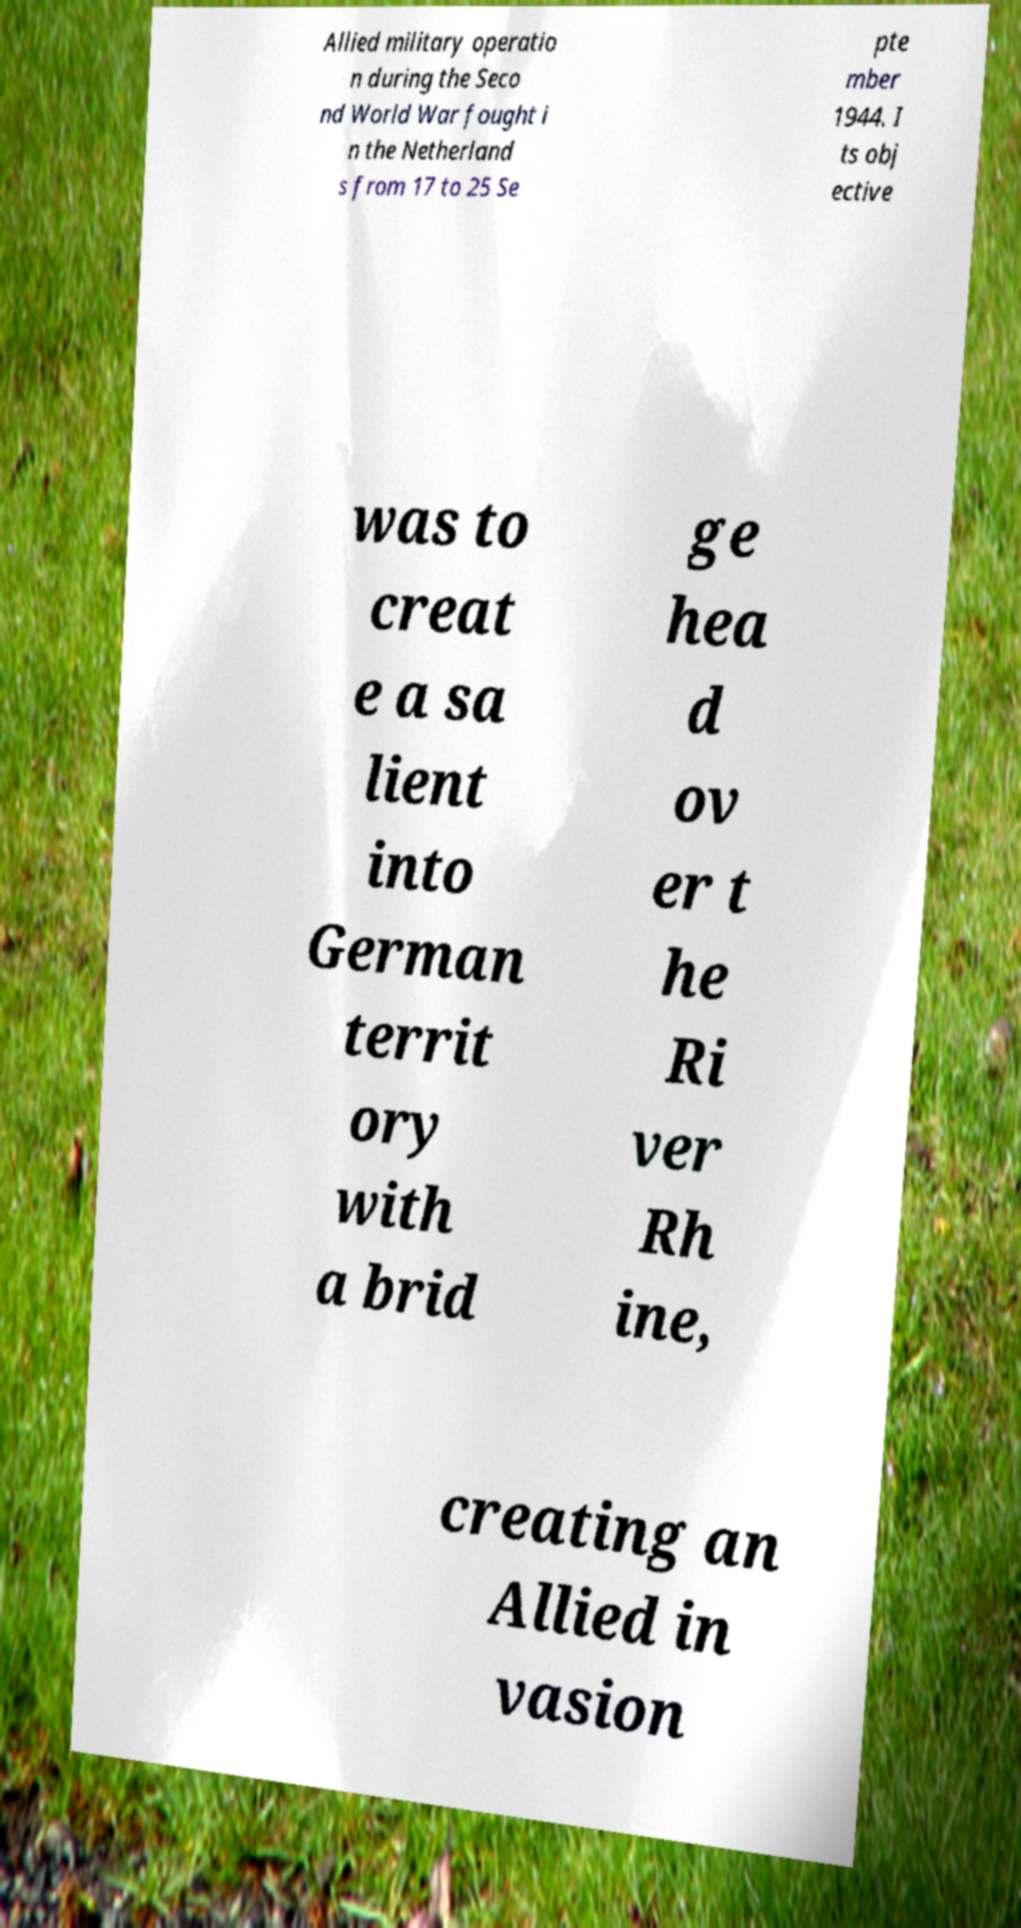There's text embedded in this image that I need extracted. Can you transcribe it verbatim? Allied military operatio n during the Seco nd World War fought i n the Netherland s from 17 to 25 Se pte mber 1944. I ts obj ective was to creat e a sa lient into German territ ory with a brid ge hea d ov er t he Ri ver Rh ine, creating an Allied in vasion 